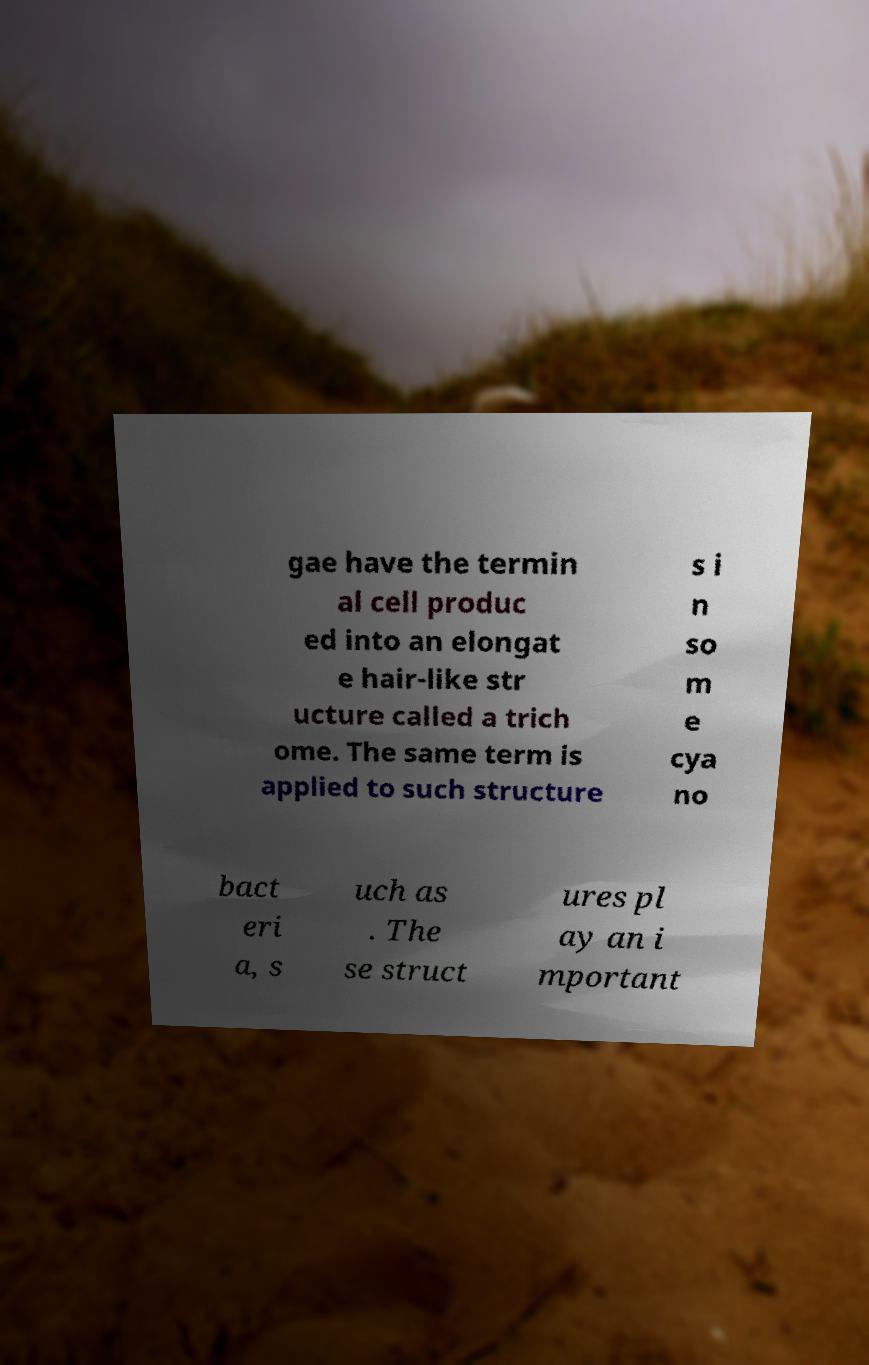Please read and relay the text visible in this image. What does it say? gae have the termin al cell produc ed into an elongat e hair-like str ucture called a trich ome. The same term is applied to such structure s i n so m e cya no bact eri a, s uch as . The se struct ures pl ay an i mportant 